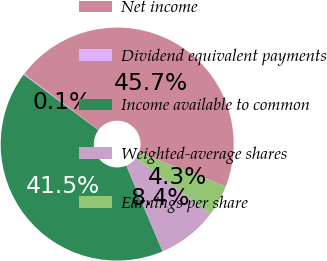Convert chart. <chart><loc_0><loc_0><loc_500><loc_500><pie_chart><fcel>Net income<fcel>Dividend equivalent payments<fcel>Income available to common<fcel>Weighted-average shares<fcel>Earnings per share<nl><fcel>45.66%<fcel>0.12%<fcel>41.51%<fcel>8.43%<fcel>4.28%<nl></chart> 